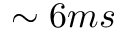Convert formula to latex. <formula><loc_0><loc_0><loc_500><loc_500>\sim 6 m s</formula> 